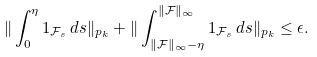<formula> <loc_0><loc_0><loc_500><loc_500>\| \int _ { 0 } ^ { \eta } 1 _ { \mathcal { F } _ { s } } \, d s \| _ { p _ { k } } + \| \int _ { \| \mathcal { F } \| _ { \infty } - \eta } ^ { \| \mathcal { F } \| _ { \infty } } 1 _ { \mathcal { F } _ { s } } \, d s \| _ { p _ { k } } \leq \epsilon .</formula> 